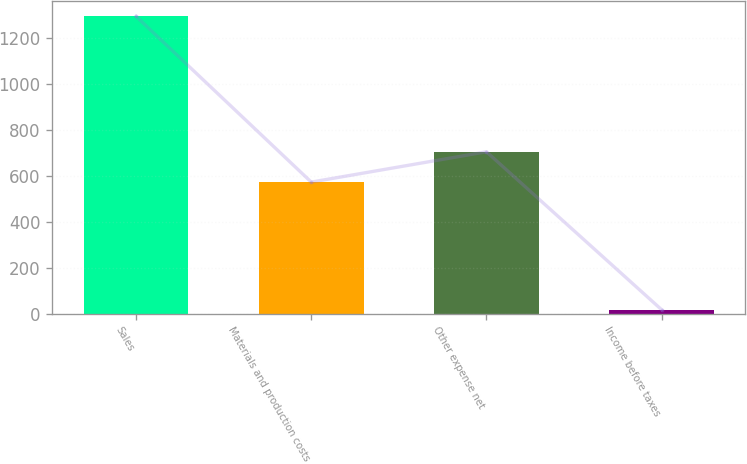Convert chart to OTSL. <chart><loc_0><loc_0><loc_500><loc_500><bar_chart><fcel>Sales<fcel>Materials and production costs<fcel>Other expense net<fcel>Income before taxes<nl><fcel>1295<fcel>573<fcel>705<fcel>17<nl></chart> 